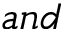<formula> <loc_0><loc_0><loc_500><loc_500>a n d</formula> 